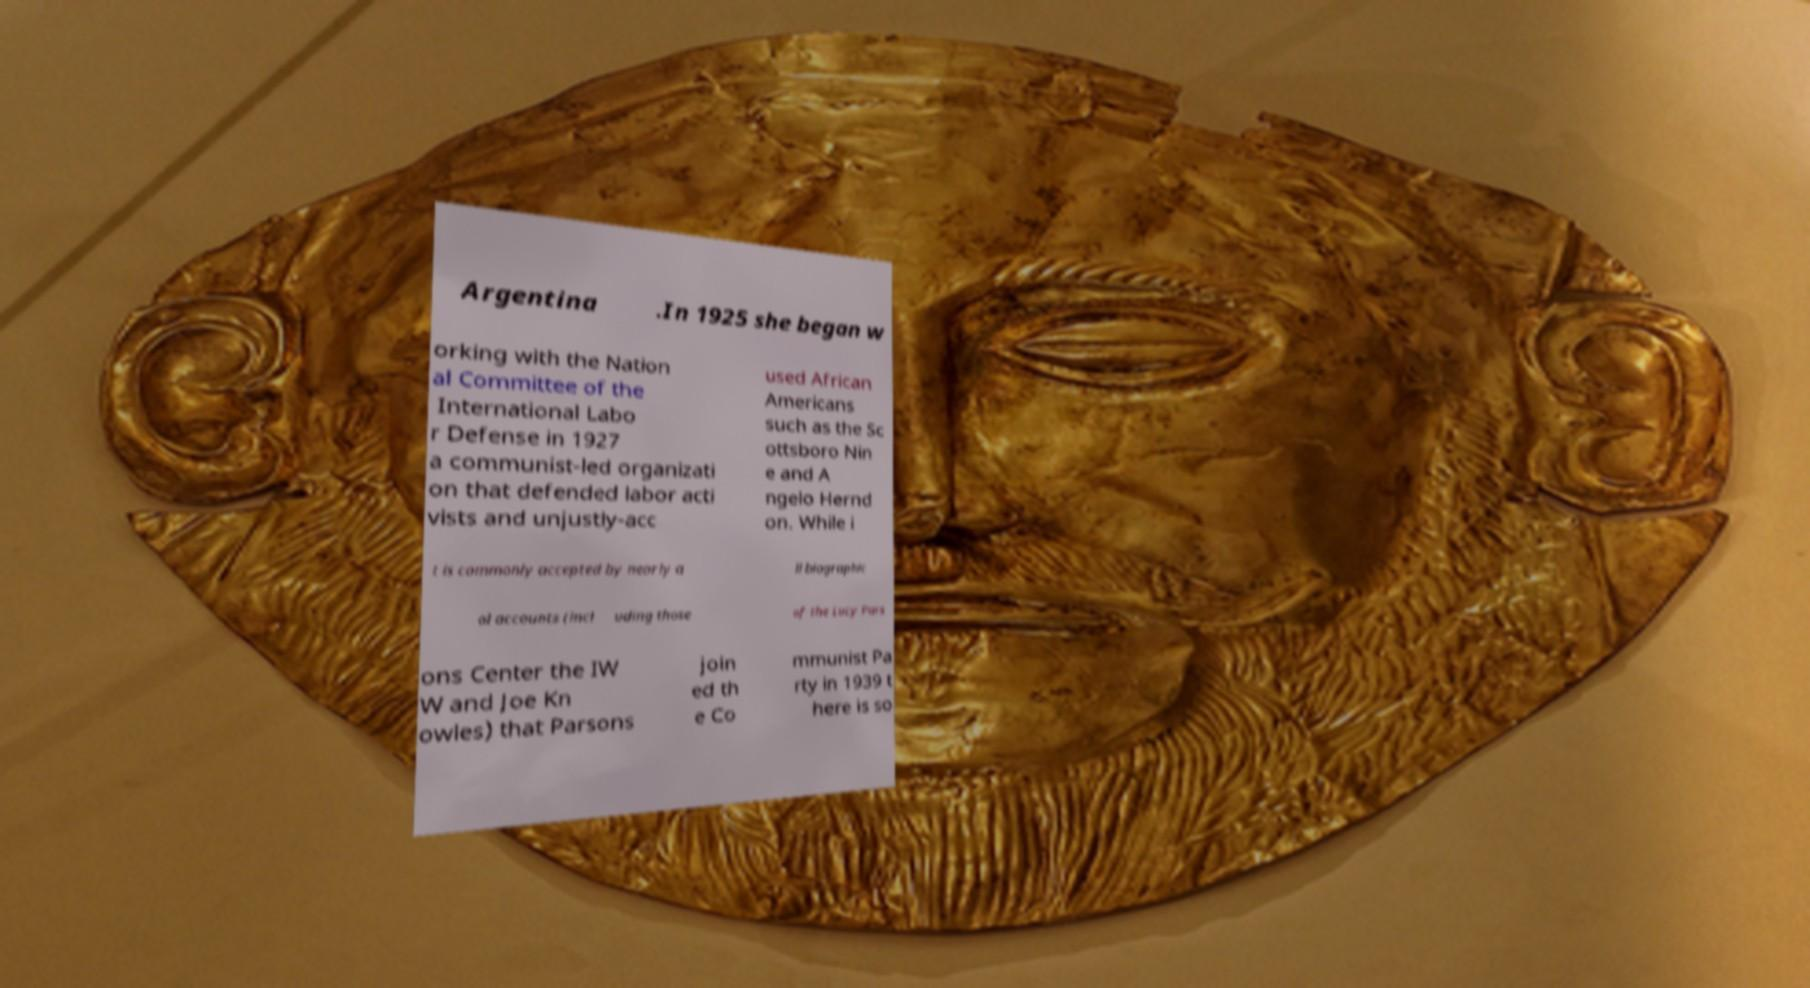I need the written content from this picture converted into text. Can you do that? Argentina .In 1925 she began w orking with the Nation al Committee of the International Labo r Defense in 1927 a communist-led organizati on that defended labor acti vists and unjustly-acc used African Americans such as the Sc ottsboro Nin e and A ngelo Hernd on. While i t is commonly accepted by nearly a ll biographic al accounts (incl uding those of the Lucy Pars ons Center the IW W and Joe Kn owles) that Parsons join ed th e Co mmunist Pa rty in 1939 t here is so 